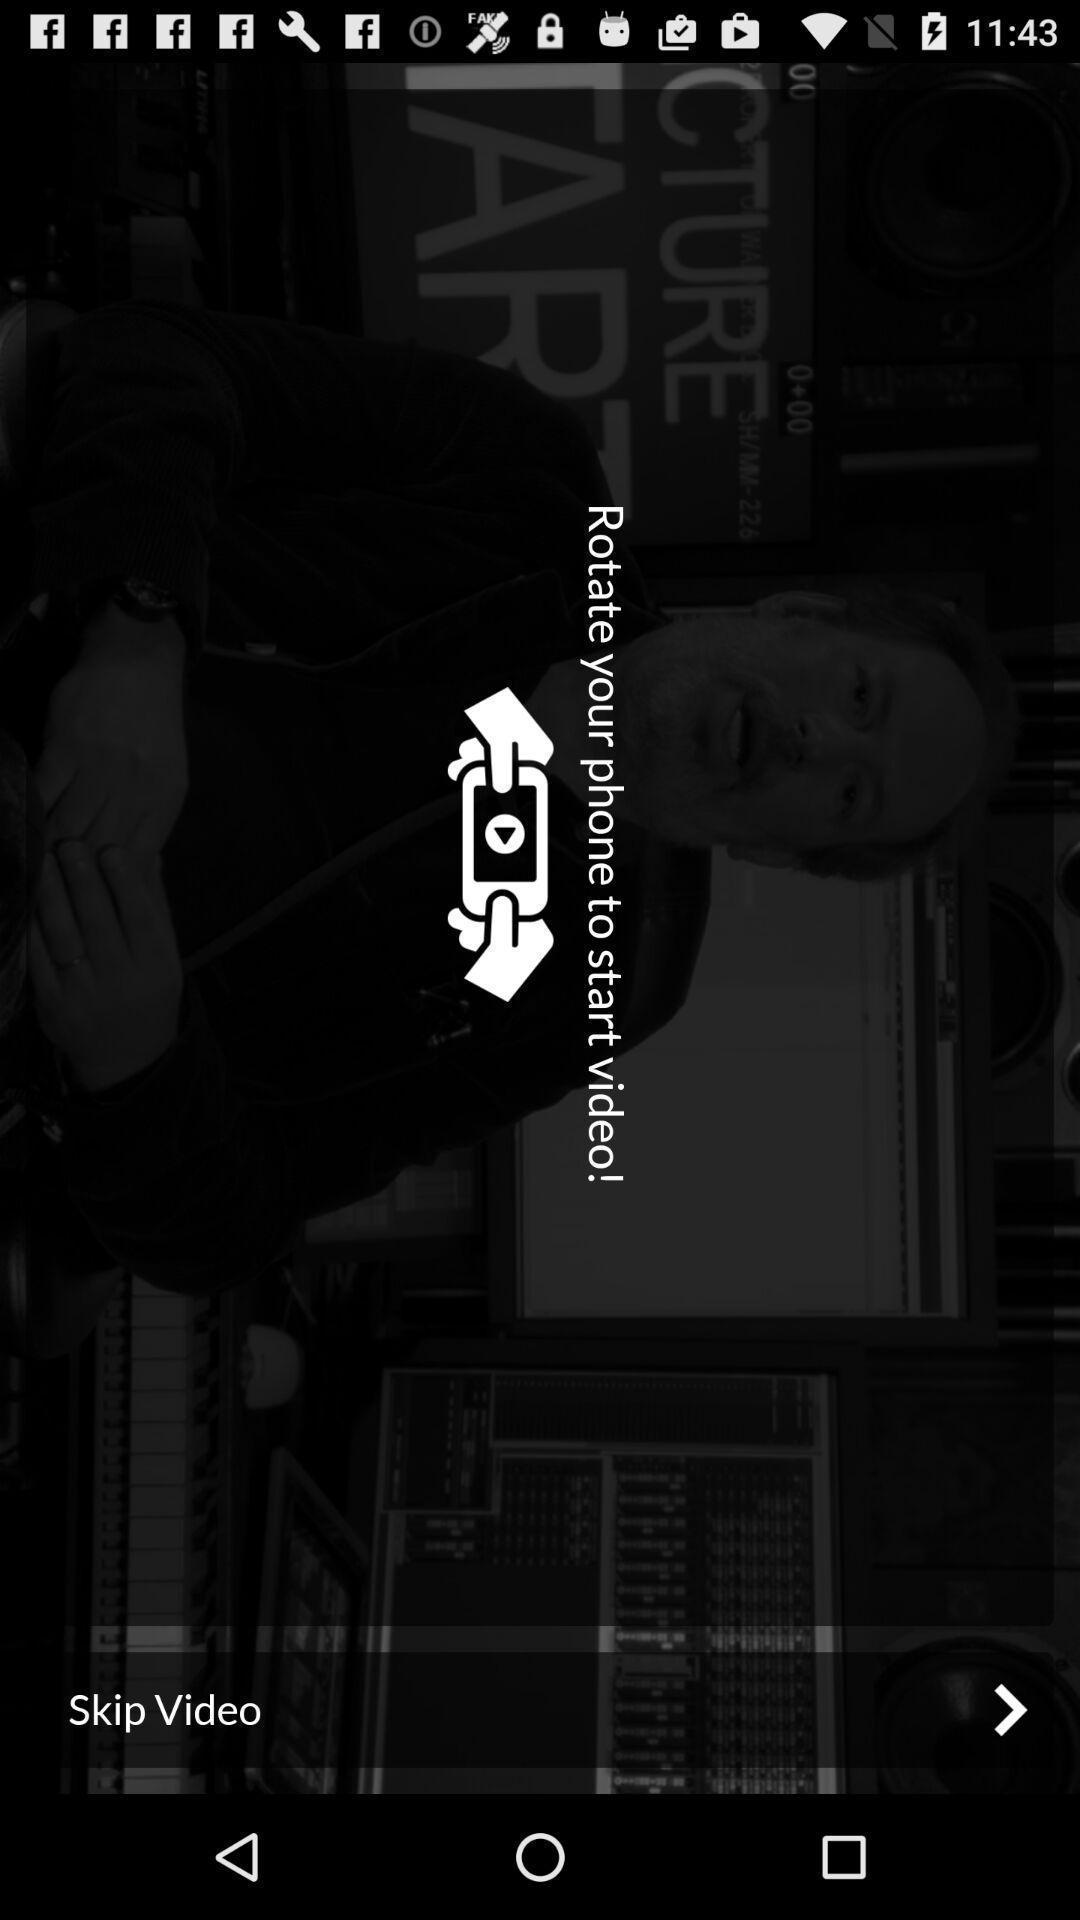Give me a narrative description of this picture. Window displaying a video playing. 